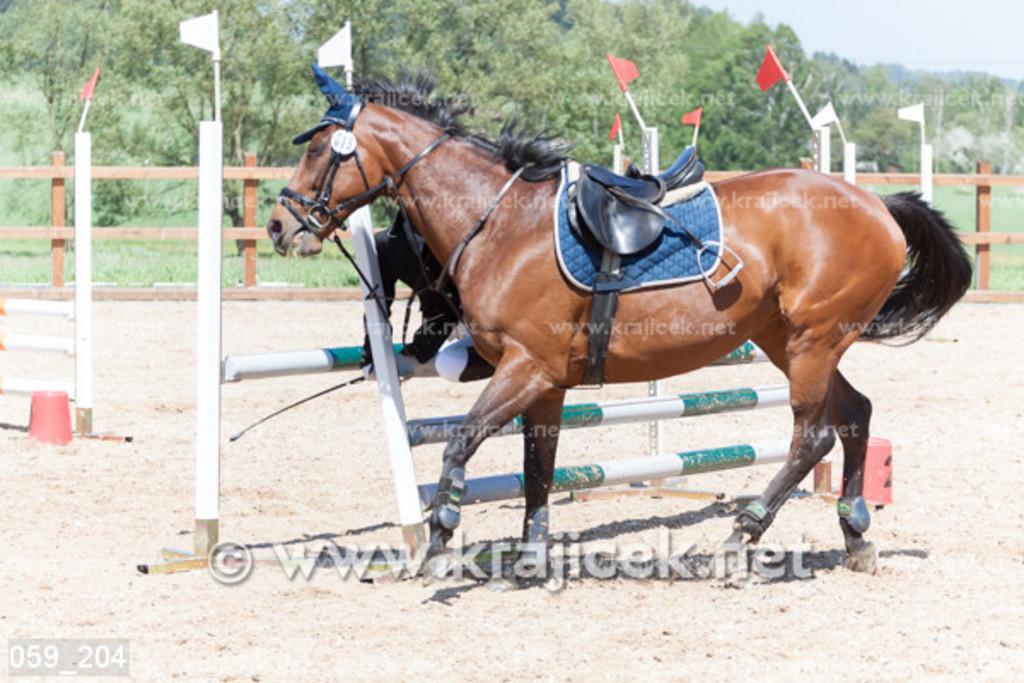Describe this image in one or two sentences. In this image I can see a horse. There are flags and fences. There are trees at the back. 